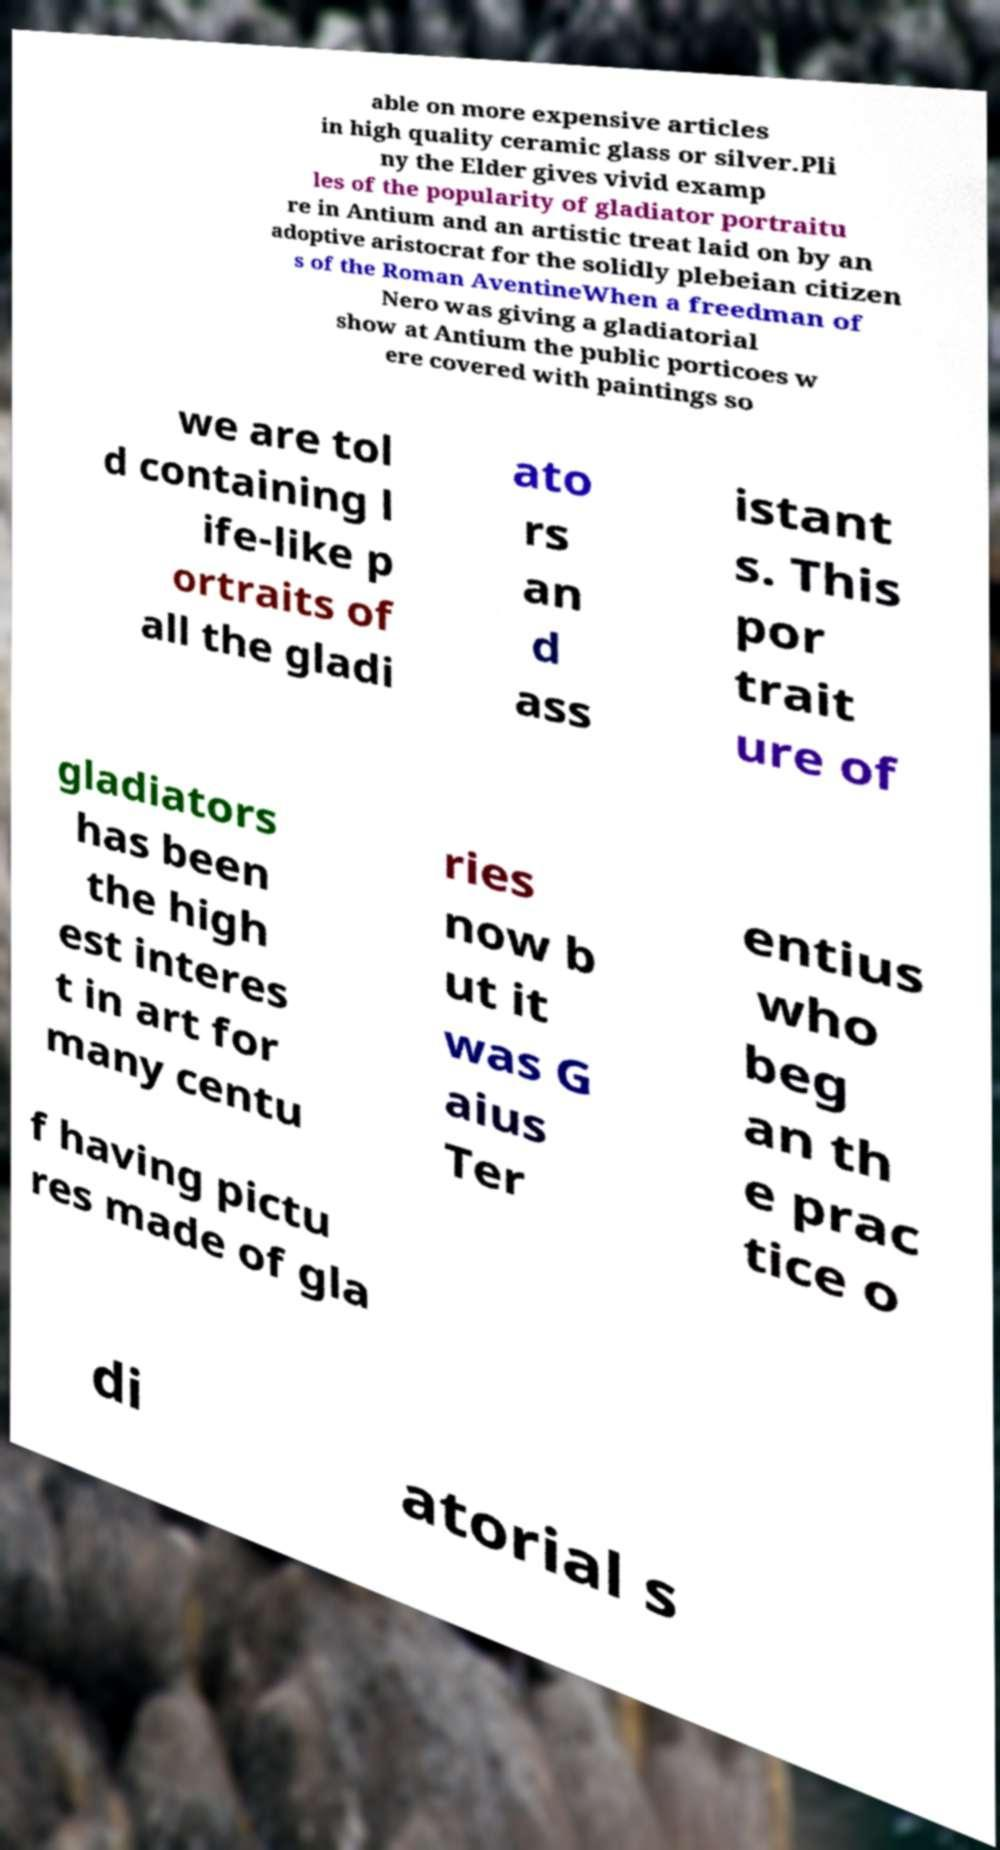Can you accurately transcribe the text from the provided image for me? able on more expensive articles in high quality ceramic glass or silver.Pli ny the Elder gives vivid examp les of the popularity of gladiator portraitu re in Antium and an artistic treat laid on by an adoptive aristocrat for the solidly plebeian citizen s of the Roman AventineWhen a freedman of Nero was giving a gladiatorial show at Antium the public porticoes w ere covered with paintings so we are tol d containing l ife-like p ortraits of all the gladi ato rs an d ass istant s. This por trait ure of gladiators has been the high est interes t in art for many centu ries now b ut it was G aius Ter entius who beg an th e prac tice o f having pictu res made of gla di atorial s 